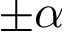Convert formula to latex. <formula><loc_0><loc_0><loc_500><loc_500>\pm \alpha</formula> 